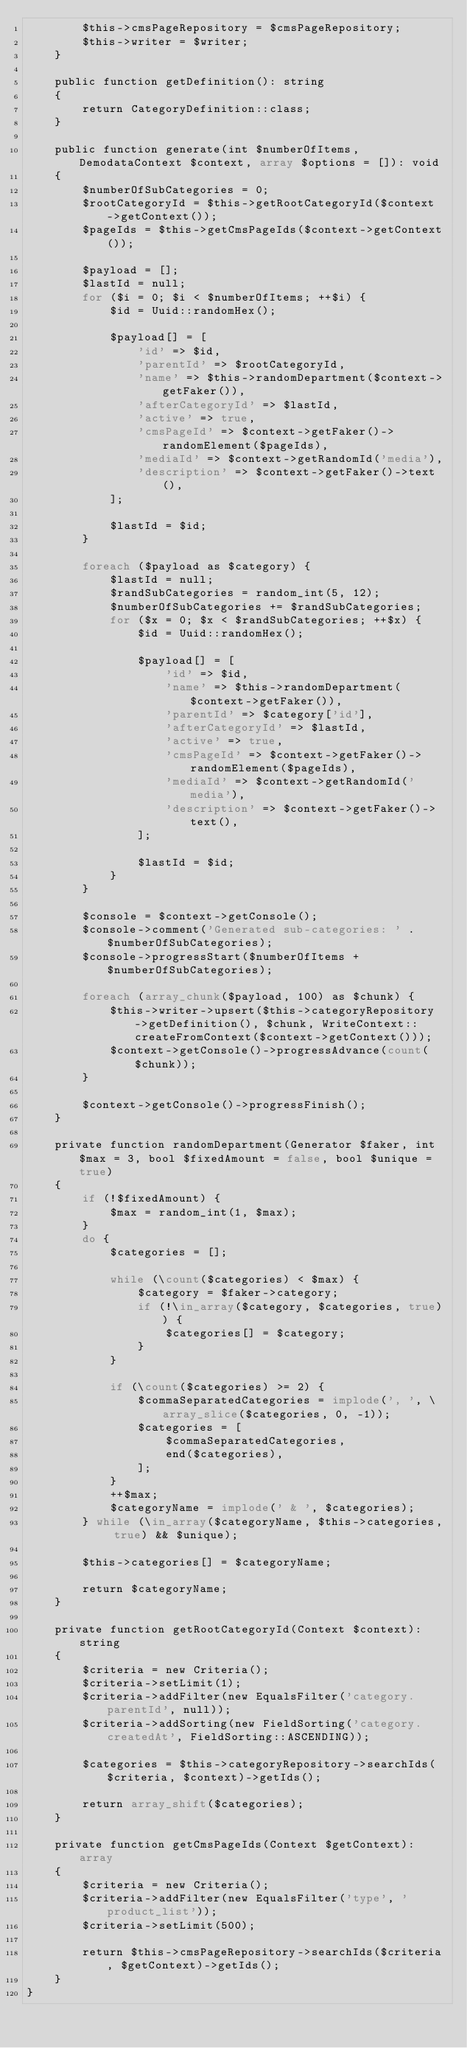Convert code to text. <code><loc_0><loc_0><loc_500><loc_500><_PHP_>        $this->cmsPageRepository = $cmsPageRepository;
        $this->writer = $writer;
    }

    public function getDefinition(): string
    {
        return CategoryDefinition::class;
    }

    public function generate(int $numberOfItems, DemodataContext $context, array $options = []): void
    {
        $numberOfSubCategories = 0;
        $rootCategoryId = $this->getRootCategoryId($context->getContext());
        $pageIds = $this->getCmsPageIds($context->getContext());

        $payload = [];
        $lastId = null;
        for ($i = 0; $i < $numberOfItems; ++$i) {
            $id = Uuid::randomHex();

            $payload[] = [
                'id' => $id,
                'parentId' => $rootCategoryId,
                'name' => $this->randomDepartment($context->getFaker()),
                'afterCategoryId' => $lastId,
                'active' => true,
                'cmsPageId' => $context->getFaker()->randomElement($pageIds),
                'mediaId' => $context->getRandomId('media'),
                'description' => $context->getFaker()->text(),
            ];

            $lastId = $id;
        }

        foreach ($payload as $category) {
            $lastId = null;
            $randSubCategories = random_int(5, 12);
            $numberOfSubCategories += $randSubCategories;
            for ($x = 0; $x < $randSubCategories; ++$x) {
                $id = Uuid::randomHex();

                $payload[] = [
                    'id' => $id,
                    'name' => $this->randomDepartment($context->getFaker()),
                    'parentId' => $category['id'],
                    'afterCategoryId' => $lastId,
                    'active' => true,
                    'cmsPageId' => $context->getFaker()->randomElement($pageIds),
                    'mediaId' => $context->getRandomId('media'),
                    'description' => $context->getFaker()->text(),
                ];

                $lastId = $id;
            }
        }

        $console = $context->getConsole();
        $console->comment('Generated sub-categories: ' . $numberOfSubCategories);
        $console->progressStart($numberOfItems + $numberOfSubCategories);

        foreach (array_chunk($payload, 100) as $chunk) {
            $this->writer->upsert($this->categoryRepository->getDefinition(), $chunk, WriteContext::createFromContext($context->getContext()));
            $context->getConsole()->progressAdvance(count($chunk));
        }

        $context->getConsole()->progressFinish();
    }

    private function randomDepartment(Generator $faker, int $max = 3, bool $fixedAmount = false, bool $unique = true)
    {
        if (!$fixedAmount) {
            $max = random_int(1, $max);
        }
        do {
            $categories = [];

            while (\count($categories) < $max) {
                $category = $faker->category;
                if (!\in_array($category, $categories, true)) {
                    $categories[] = $category;
                }
            }

            if (\count($categories) >= 2) {
                $commaSeparatedCategories = implode(', ', \array_slice($categories, 0, -1));
                $categories = [
                    $commaSeparatedCategories,
                    end($categories),
                ];
            }
            ++$max;
            $categoryName = implode(' & ', $categories);
        } while (\in_array($categoryName, $this->categories, true) && $unique);

        $this->categories[] = $categoryName;

        return $categoryName;
    }

    private function getRootCategoryId(Context $context): string
    {
        $criteria = new Criteria();
        $criteria->setLimit(1);
        $criteria->addFilter(new EqualsFilter('category.parentId', null));
        $criteria->addSorting(new FieldSorting('category.createdAt', FieldSorting::ASCENDING));

        $categories = $this->categoryRepository->searchIds($criteria, $context)->getIds();

        return array_shift($categories);
    }

    private function getCmsPageIds(Context $getContext): array
    {
        $criteria = new Criteria();
        $criteria->addFilter(new EqualsFilter('type', 'product_list'));
        $criteria->setLimit(500);

        return $this->cmsPageRepository->searchIds($criteria, $getContext)->getIds();
    }
}
</code> 